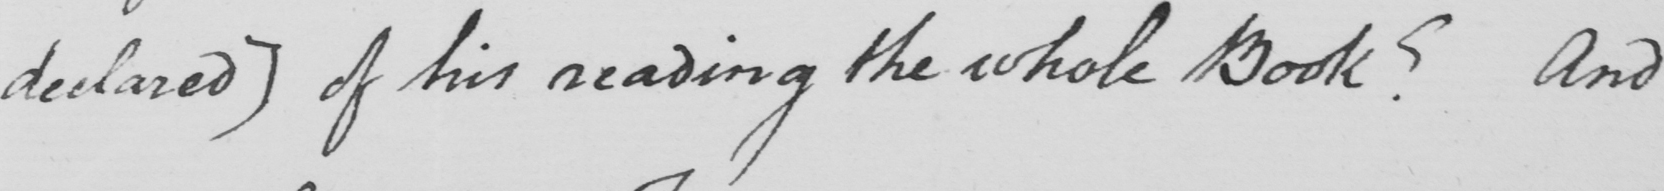What text is written in this handwritten line? declared] of his reading the whole Book? And 